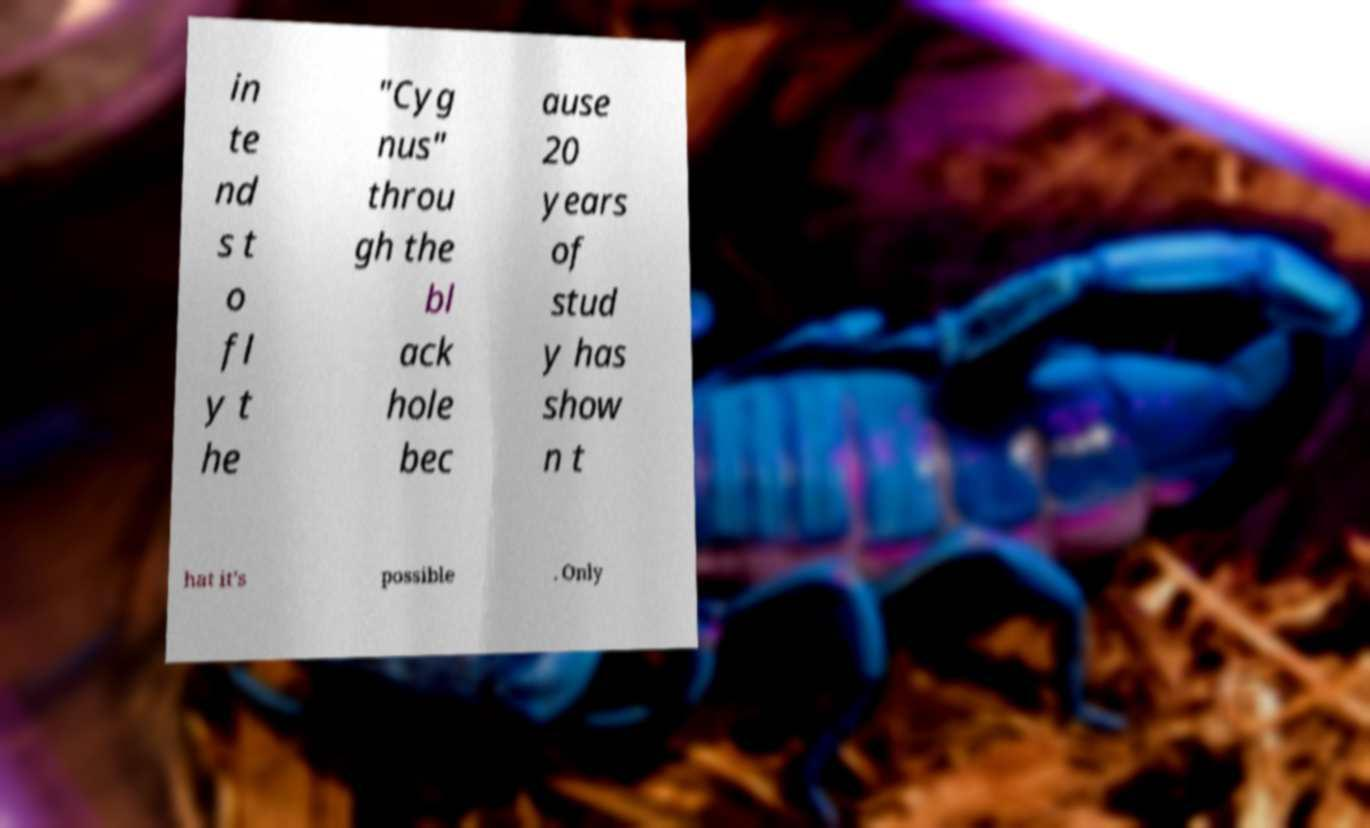Could you extract and type out the text from this image? in te nd s t o fl y t he "Cyg nus" throu gh the bl ack hole bec ause 20 years of stud y has show n t hat it's possible . Only 